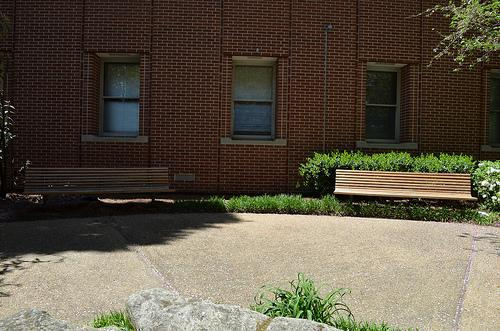What are the main colors present in this image? The main colors present in the image are brown, red, green, and gray. Please describe the place where the benches are located in the image. The benches are located in front of a red brick building, with a paved walkway and a cement area in front of them. Identify the primary objects and their features in the picture. Two brown wooden benches, one on the left and one on the right, bushes behind the bench on the right, windows on a red brick building, a crack in a sidewalk, a large rock near grass, and a vent on a building. Describe any shadows present in the image. Tree shadow on concrete, shadow of leaves on the path, and possibly some shadows cast by the benches and the buildings are present in the image. Mention the objects found near the right bench in the image. The objects found near the right bench include the bushes behind it, the middle window on a building behind it, and the windowsill of the window on the right behind the bench. How many benches are there in the image and describe their color? There are two benches in the image, and they are brown in color. List the different types of windows that can be seen in the image. Sash windows, windows on a brick building, and windows on the side of a building can be seen in the image. Are there any objects that indicate the presence of a sidewalk or walkway? Yes, there is a paved walkway, a large sidewalk, a crack in the sidewalk, and grass growing beside the path. What type of building can be seen in the image, and what is it made of? A large red brick building can be seen in the image. What type of plant life can be observed in the image? Bushes behind a bench, grass surrounding a rock, a lush green leafy plant and a shrub with white flowers can be observed in the image. 